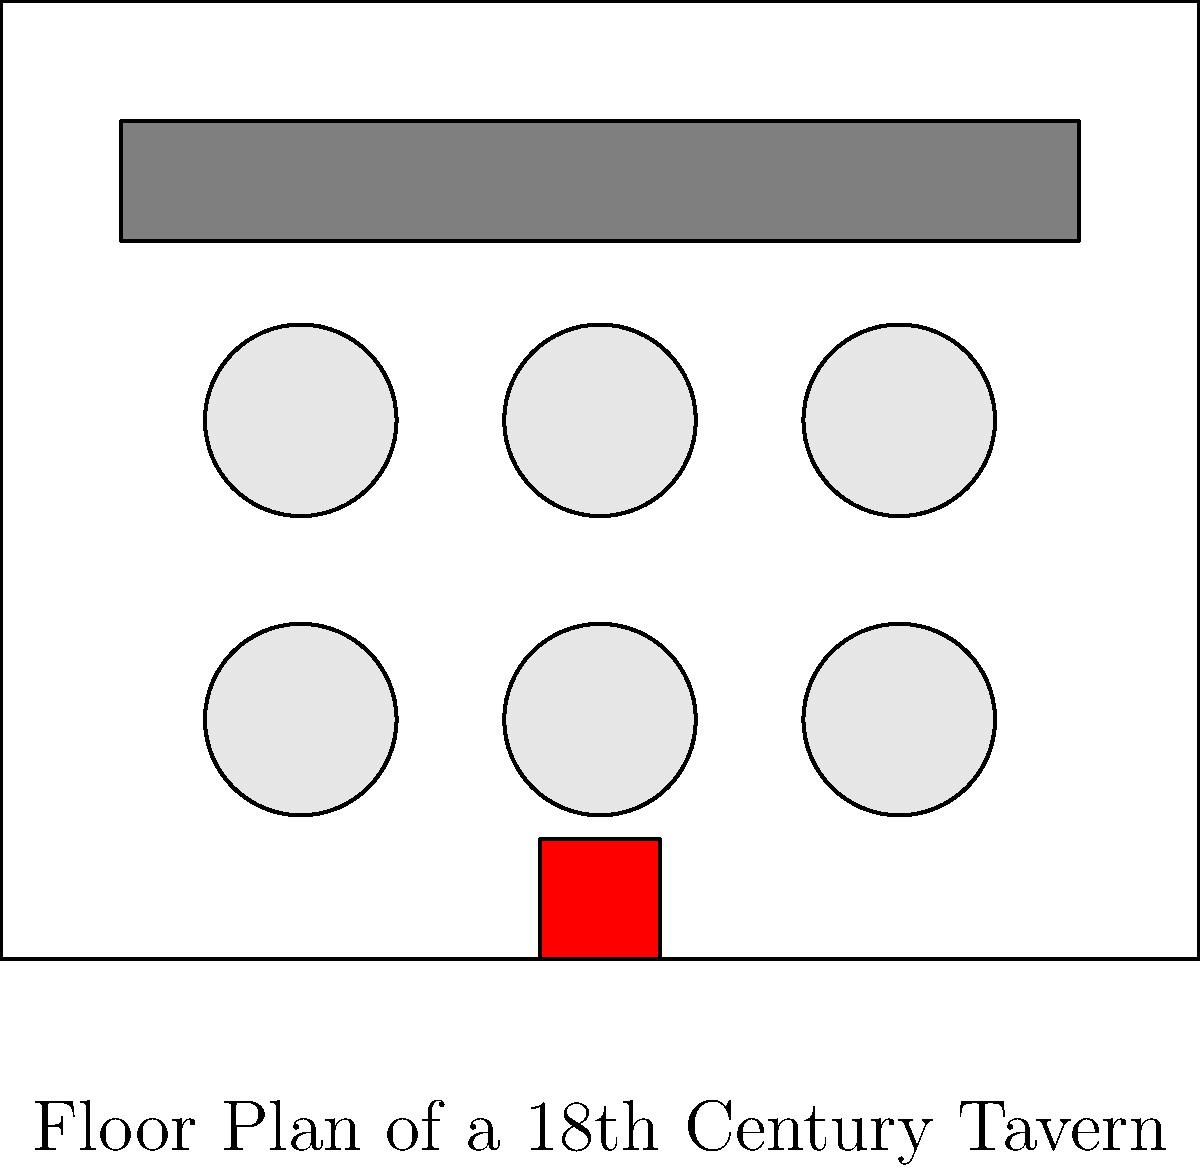Analyze the floor plan of this 18th-century tavern. Which architectural feature, common in historical drinking establishments, is prominently displayed at the bottom of the diagram, and how does its placement contribute to the tavern's atmosphere and functionality? To answer this question, let's analyze the floor plan step-by-step:

1. Examine the overall layout: The diagram shows a rectangular room with various elements typical of a tavern.

2. Identify key features:
   a) A long bar counter at the top of the diagram
   b) Several circular tables in the main area
   c) A small rectangular feature at the bottom center of the diagram

3. Recognize the feature at the bottom: This rectangular element represents a fireplace.

4. Understand the significance of fireplaces in historical taverns:
   a) Fireplaces were crucial for heating in the 18th century
   b) They provided a focal point for gatherings
   c) Fireplaces were often used for cooking in taverns

5. Analyze the fireplace's placement:
   a) It's centrally located on one of the shorter walls
   b) This position allows heat to distribute evenly throughout the room
   c) The central placement makes it visible from most areas of the tavern

6. Consider the contribution to atmosphere and functionality:
   a) Atmosphere: Creates a warm, inviting ambiance for patrons
   b) Functionality: Provides heat and potentially a cooking area
   c) Social aspect: Encourages patrons to gather around, fostering social interaction

The fireplace's central placement on the far wall optimizes its heating efficiency and creates a natural focal point for the tavern, enhancing both its practical functionality and social atmosphere.
Answer: Fireplace 